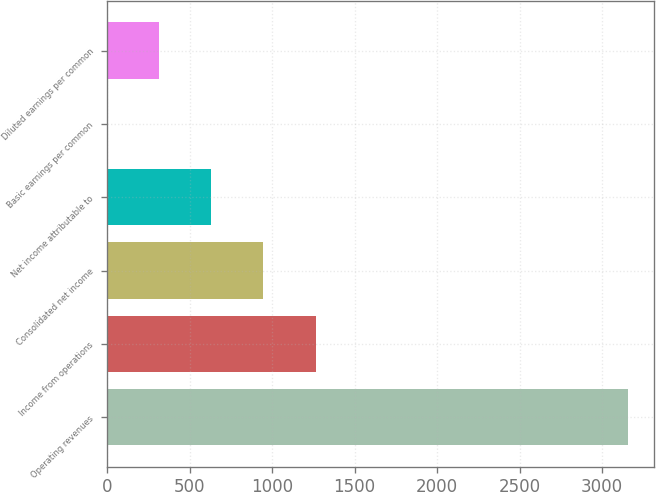Convert chart. <chart><loc_0><loc_0><loc_500><loc_500><bar_chart><fcel>Operating revenues<fcel>Income from operations<fcel>Consolidated net income<fcel>Net income attributable to<fcel>Basic earnings per common<fcel>Diluted earnings per common<nl><fcel>3158<fcel>1263.51<fcel>947.76<fcel>632.01<fcel>0.51<fcel>316.26<nl></chart> 